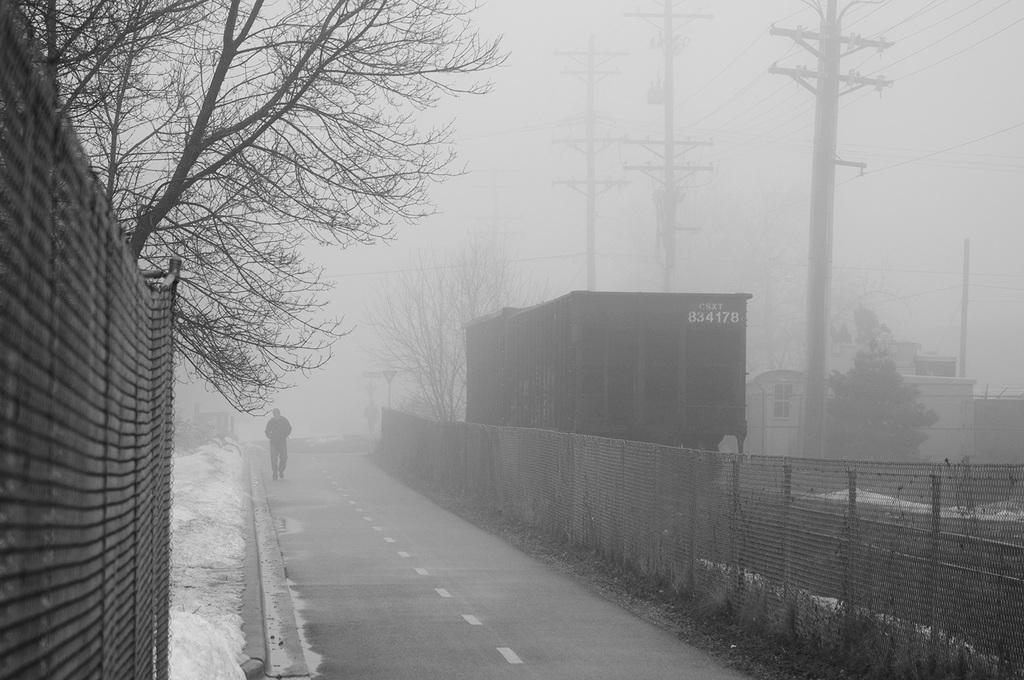Can you describe this image briefly? In this image I can see the person on the road. On both sides of the road I can see the fence and few trees. To the right I can see the buildings and poles. I can see the snow and the wall. In the background I can see the sky. 